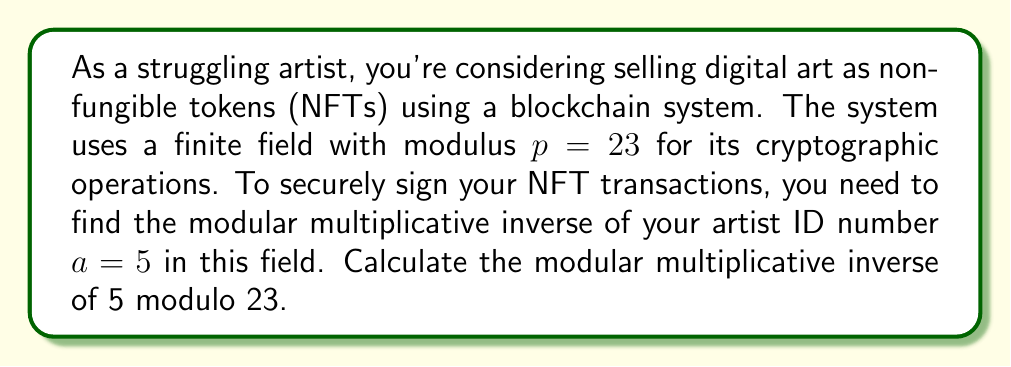Can you solve this math problem? To find the modular multiplicative inverse of 5 modulo 23, we need to find a number $x$ such that:

$$(5x) \mod 23 \equiv 1$$

We can use the extended Euclidean algorithm to solve this:

1) Start with the equation: $23 = 4 \cdot 5 + 3$
2) Then: $5 = 1 \cdot 3 + 2$
3) Finally: $3 = 1 \cdot 2 + 1$

Now, work backwards:

4) $1 = 3 - 1 \cdot 2$
5) $1 = 3 - 1 \cdot (5 - 1 \cdot 3) = 2 \cdot 3 - 1 \cdot 5$
6) $1 = 2 \cdot (23 - 4 \cdot 5) - 1 \cdot 5 = 2 \cdot 23 - 9 \cdot 5$

Therefore, $-9 \cdot 5 \equiv 1 \pmod{23}$

Since we need a positive number less than 23, we add 23 to -9 until we get a positive number:
$-9 + 23 = 14$

Verify: $14 \cdot 5 = 70 \equiv 1 \pmod{23}$

Thus, the modular multiplicative inverse of 5 modulo 23 is 14.
Answer: 14 